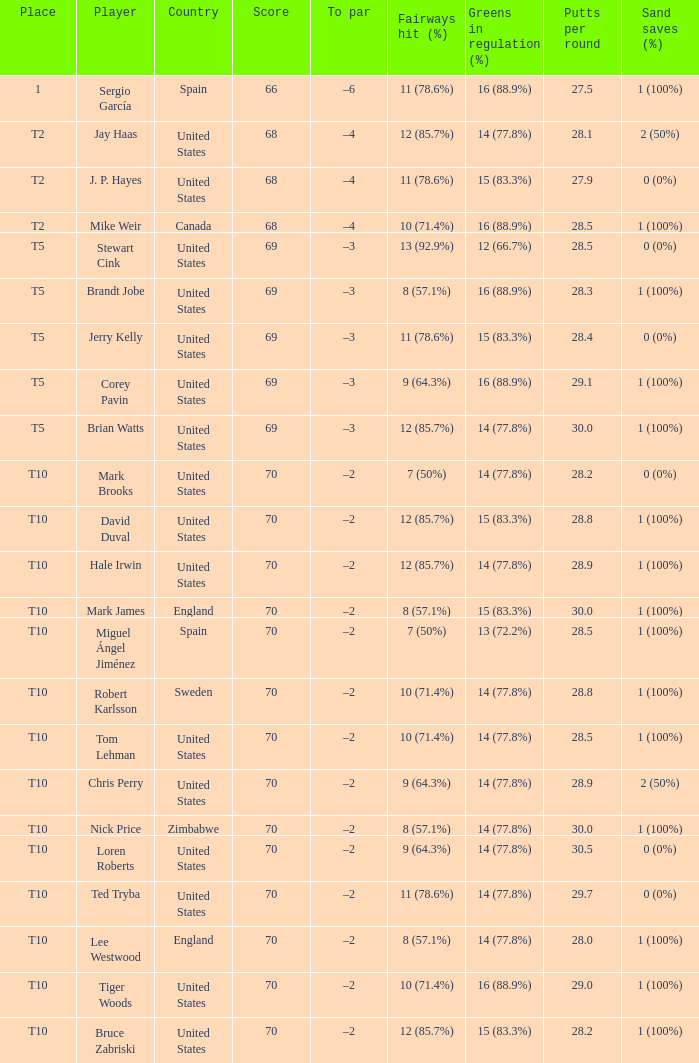What was the To par of the golfer that placed t5? –3, –3, –3, –3, –3. Write the full table. {'header': ['Place', 'Player', 'Country', 'Score', 'To par', 'Fairways hit (%)', 'Greens in regulation (%)', 'Putts per round', 'Sand saves (%)'], 'rows': [['1', 'Sergio García', 'Spain', '66', '–6', '11 (78.6%)', '16 (88.9%)', '27.5', '1 (100%)'], ['T2', 'Jay Haas', 'United States', '68', '–4', '12 (85.7%)', '14 (77.8%)', '28.1', '2 (50%)'], ['T2', 'J. P. Hayes', 'United States', '68', '–4', '11 (78.6%)', '15 (83.3%)', '27.9', '0 (0%)'], ['T2', 'Mike Weir', 'Canada', '68', '–4', '10 (71.4%)', '16 (88.9%)', '28.5', '1 (100%)'], ['T5', 'Stewart Cink', 'United States', '69', '–3', '13 (92.9%)', '12 (66.7%)', '28.5', '0 (0%)'], ['T5', 'Brandt Jobe', 'United States', '69', '–3', '8 (57.1%)', '16 (88.9%)', '28.3', '1 (100%)'], ['T5', 'Jerry Kelly', 'United States', '69', '–3', '11 (78.6%)', '15 (83.3%)', '28.4', '0 (0%)'], ['T5', 'Corey Pavin', 'United States', '69', '–3', '9 (64.3%)', '16 (88.9%)', '29.1', '1 (100%)'], ['T5', 'Brian Watts', 'United States', '69', '–3', '12 (85.7%)', '14 (77.8%)', '30.0', '1 (100%)'], ['T10', 'Mark Brooks', 'United States', '70', '–2', '7 (50%)', '14 (77.8%)', '28.2', '0 (0%)'], ['T10', 'David Duval', 'United States', '70', '–2', '12 (85.7%)', '15 (83.3%)', '28.8', '1 (100%)'], ['T10', 'Hale Irwin', 'United States', '70', '–2', '12 (85.7%)', '14 (77.8%)', '28.9', '1 (100%)'], ['T10', 'Mark James', 'England', '70', '–2', '8 (57.1%)', '15 (83.3%)', '30.0', '1 (100%)'], ['T10', 'Miguel Ángel Jiménez', 'Spain', '70', '–2', '7 (50%)', '13 (72.2%)', '28.5', '1 (100%)'], ['T10', 'Robert Karlsson', 'Sweden', '70', '–2', '10 (71.4%)', '14 (77.8%)', '28.8', '1 (100%)'], ['T10', 'Tom Lehman', 'United States', '70', '–2', '10 (71.4%)', '14 (77.8%)', '28.5', '1 (100%)'], ['T10', 'Chris Perry', 'United States', '70', '–2', '9 (64.3%)', '14 (77.8%)', '28.9', '2 (50%)'], ['T10', 'Nick Price', 'Zimbabwe', '70', '–2', '8 (57.1%)', '14 (77.8%)', '30.0', '1 (100%)'], ['T10', 'Loren Roberts', 'United States', '70', '–2', '9 (64.3%)', '14 (77.8%)', '30.5', '0 (0%)'], ['T10', 'Ted Tryba', 'United States', '70', '–2', '11 (78.6%)', '14 (77.8%)', '29.7', '0 (0%)'], ['T10', 'Lee Westwood', 'England', '70', '–2', '8 (57.1%)', '14 (77.8%)', '28.0', '1 (100%)'], ['T10', 'Tiger Woods', 'United States', '70', '–2', '10 (71.4%)', '16 (88.9%)', '29.0', '1 (100%)'], ['T10', 'Bruce Zabriski', 'United States', '70', '–2', '12 (85.7%)', '15 (83.3%)', '28.2', '1 (100%)']]} 